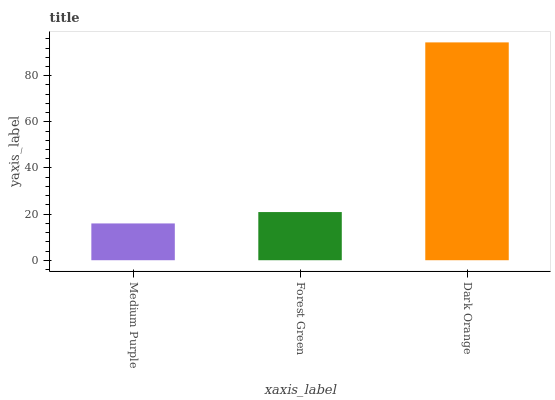Is Medium Purple the minimum?
Answer yes or no. Yes. Is Dark Orange the maximum?
Answer yes or no. Yes. Is Forest Green the minimum?
Answer yes or no. No. Is Forest Green the maximum?
Answer yes or no. No. Is Forest Green greater than Medium Purple?
Answer yes or no. Yes. Is Medium Purple less than Forest Green?
Answer yes or no. Yes. Is Medium Purple greater than Forest Green?
Answer yes or no. No. Is Forest Green less than Medium Purple?
Answer yes or no. No. Is Forest Green the high median?
Answer yes or no. Yes. Is Forest Green the low median?
Answer yes or no. Yes. Is Medium Purple the high median?
Answer yes or no. No. Is Dark Orange the low median?
Answer yes or no. No. 